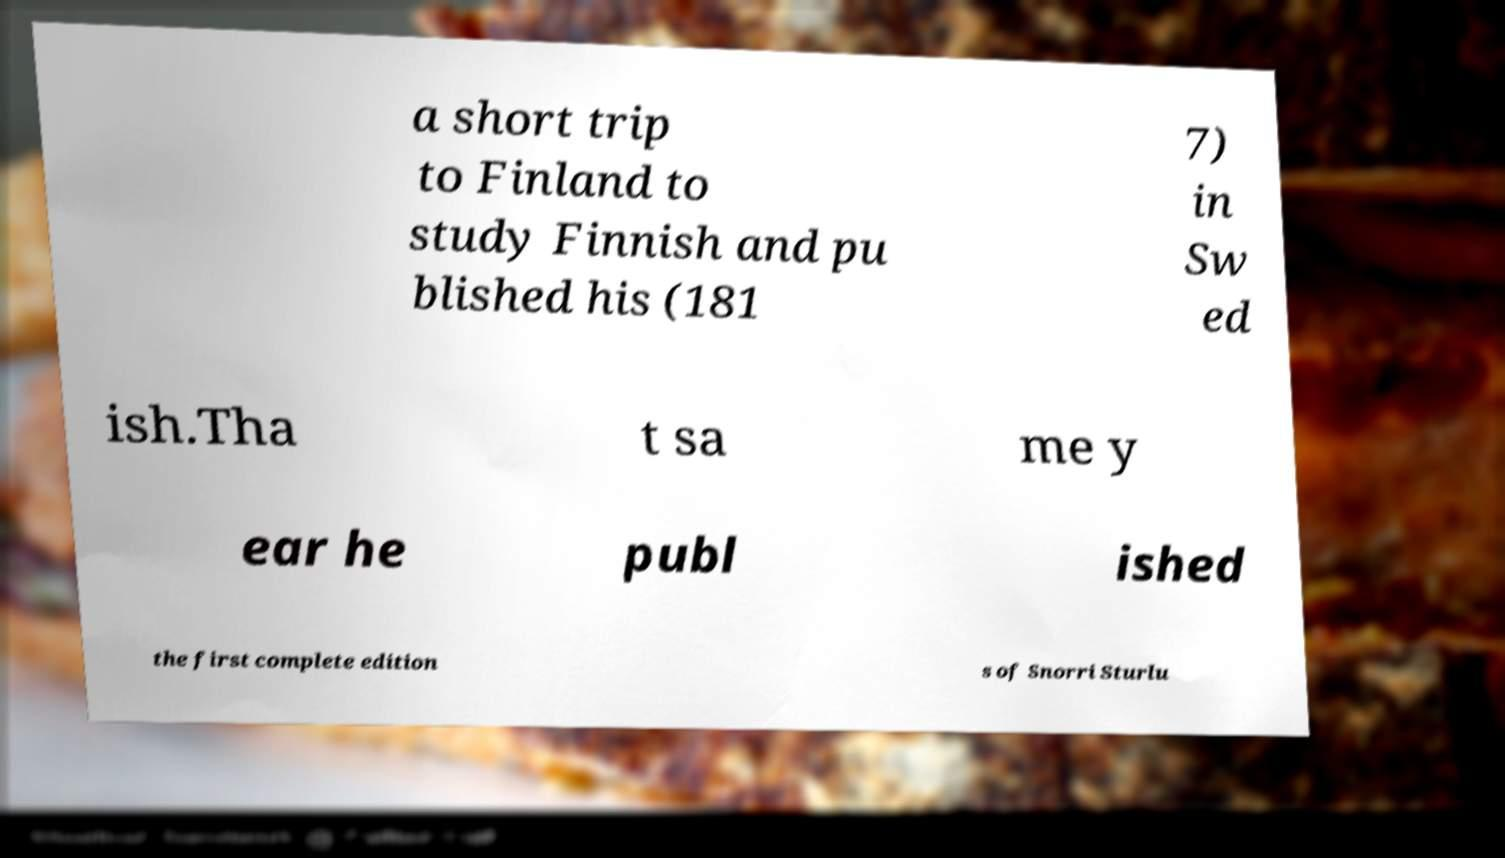Could you assist in decoding the text presented in this image and type it out clearly? a short trip to Finland to study Finnish and pu blished his (181 7) in Sw ed ish.Tha t sa me y ear he publ ished the first complete edition s of Snorri Sturlu 